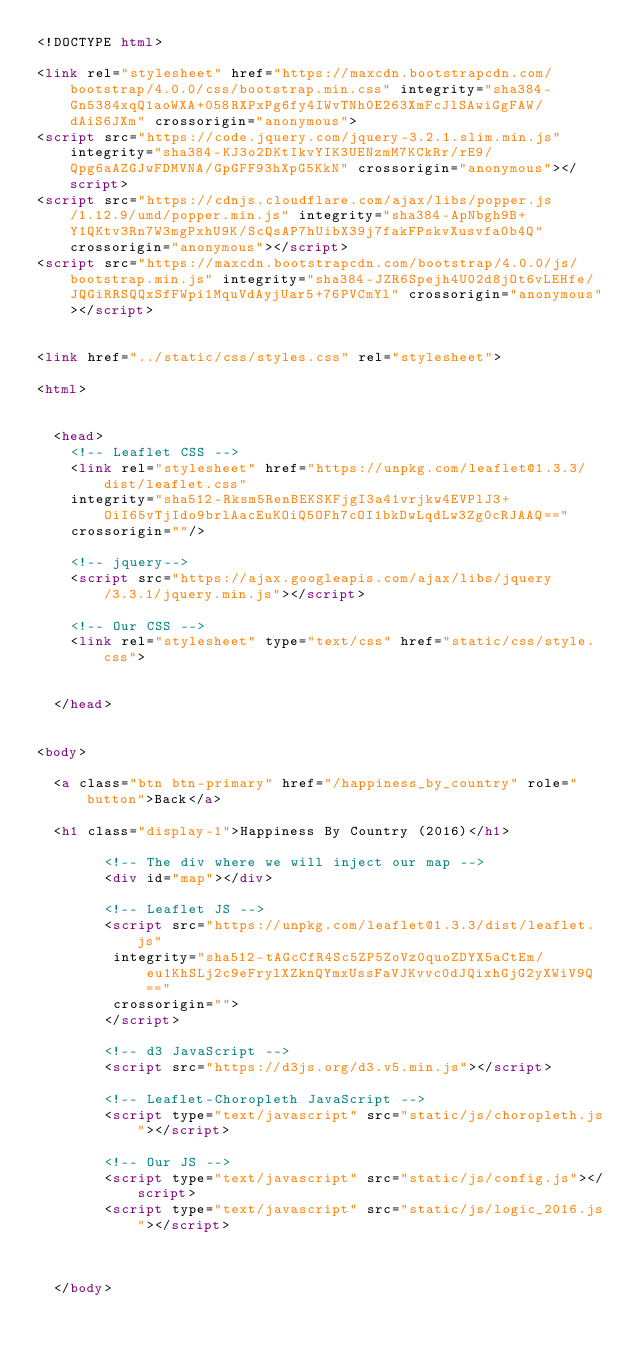<code> <loc_0><loc_0><loc_500><loc_500><_HTML_><!DOCTYPE html>

<link rel="stylesheet" href="https://maxcdn.bootstrapcdn.com/bootstrap/4.0.0/css/bootstrap.min.css" integrity="sha384-Gn5384xqQ1aoWXA+058RXPxPg6fy4IWvTNh0E263XmFcJlSAwiGgFAW/dAiS6JXm" crossorigin="anonymous">
<script src="https://code.jquery.com/jquery-3.2.1.slim.min.js" integrity="sha384-KJ3o2DKtIkvYIK3UENzmM7KCkRr/rE9/Qpg6aAZGJwFDMVNA/GpGFF93hXpG5KkN" crossorigin="anonymous"></script>
<script src="https://cdnjs.cloudflare.com/ajax/libs/popper.js/1.12.9/umd/popper.min.js" integrity="sha384-ApNbgh9B+Y1QKtv3Rn7W3mgPxhU9K/ScQsAP7hUibX39j7fakFPskvXusvfa0b4Q" crossorigin="anonymous"></script>
<script src="https://maxcdn.bootstrapcdn.com/bootstrap/4.0.0/js/bootstrap.min.js" integrity="sha384-JZR6Spejh4U02d8jOt6vLEHfe/JQGiRRSQQxSfFWpi1MquVdAyjUar5+76PVCmYl" crossorigin="anonymous"></script>


<link href="../static/css/styles.css" rel="stylesheet">

<html>


  <head>
    <!-- Leaflet CSS -->
    <link rel="stylesheet" href="https://unpkg.com/leaflet@1.3.3/dist/leaflet.css"
    integrity="sha512-Rksm5RenBEKSKFjgI3a41vrjkw4EVPlJ3+OiI65vTjIdo9brlAacEuKOiQ5OFh7cOI1bkDwLqdLw3Zg0cRJAAQ=="
    crossorigin=""/>

    <!-- jquery-->
    <script src="https://ajax.googleapis.com/ajax/libs/jquery/3.3.1/jquery.min.js"></script>

    <!-- Our CSS -->
    <link rel="stylesheet" type="text/css" href="static/css/style.css">

    
  </head>


<body>
  
  <a class="btn btn-primary" href="/happiness_by_country" role="button">Back</a>

  <h1 class="display-1">Happiness By Country (2016)</h1>
 
        <!-- The div where we will inject our map -->
        <div id="map"></div>

        <!-- Leaflet JS -->
        <script src="https://unpkg.com/leaflet@1.3.3/dist/leaflet.js" 
         integrity="sha512-tAGcCfR4Sc5ZP5ZoVz0quoZDYX5aCtEm/eu1KhSLj2c9eFrylXZknQYmxUssFaVJKvvc0dJQixhGjG2yXWiV9Q==" 
         crossorigin="">
        </script>

        <!-- d3 JavaScript -->
        <script src="https://d3js.org/d3.v5.min.js"></script>

        <!-- Leaflet-Choropleth JavaScript -->
        <script type="text/javascript" src="static/js/choropleth.js"></script>

        <!-- Our JS -->
        <script type="text/javascript" src="static/js/config.js"></script>
        <script type="text/javascript" src="static/js/logic_2016.js"></script>
 
 
  
  </body></code> 